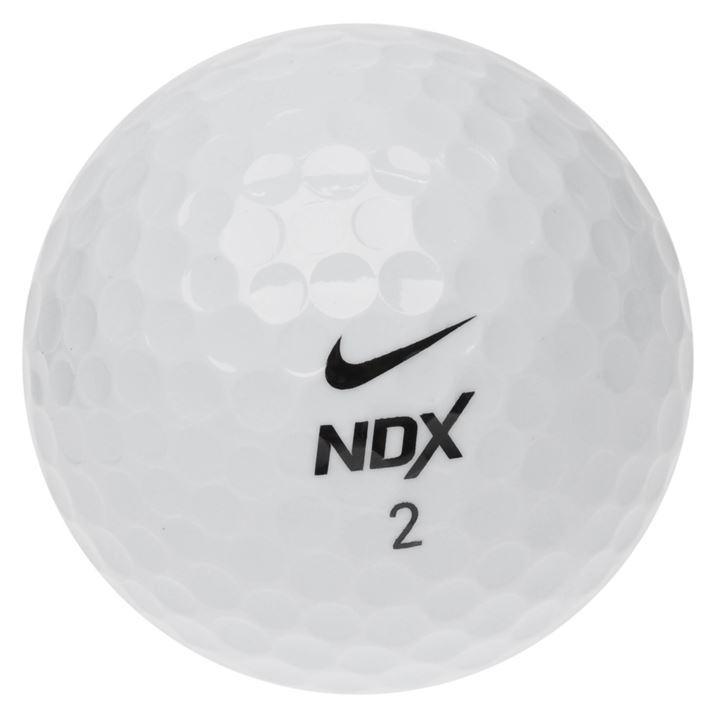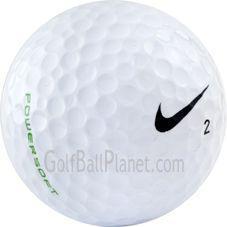The first image is the image on the left, the second image is the image on the right. For the images shown, is this caption "The number 1 is on exactly one of the balls." true? Answer yes or no. No. 